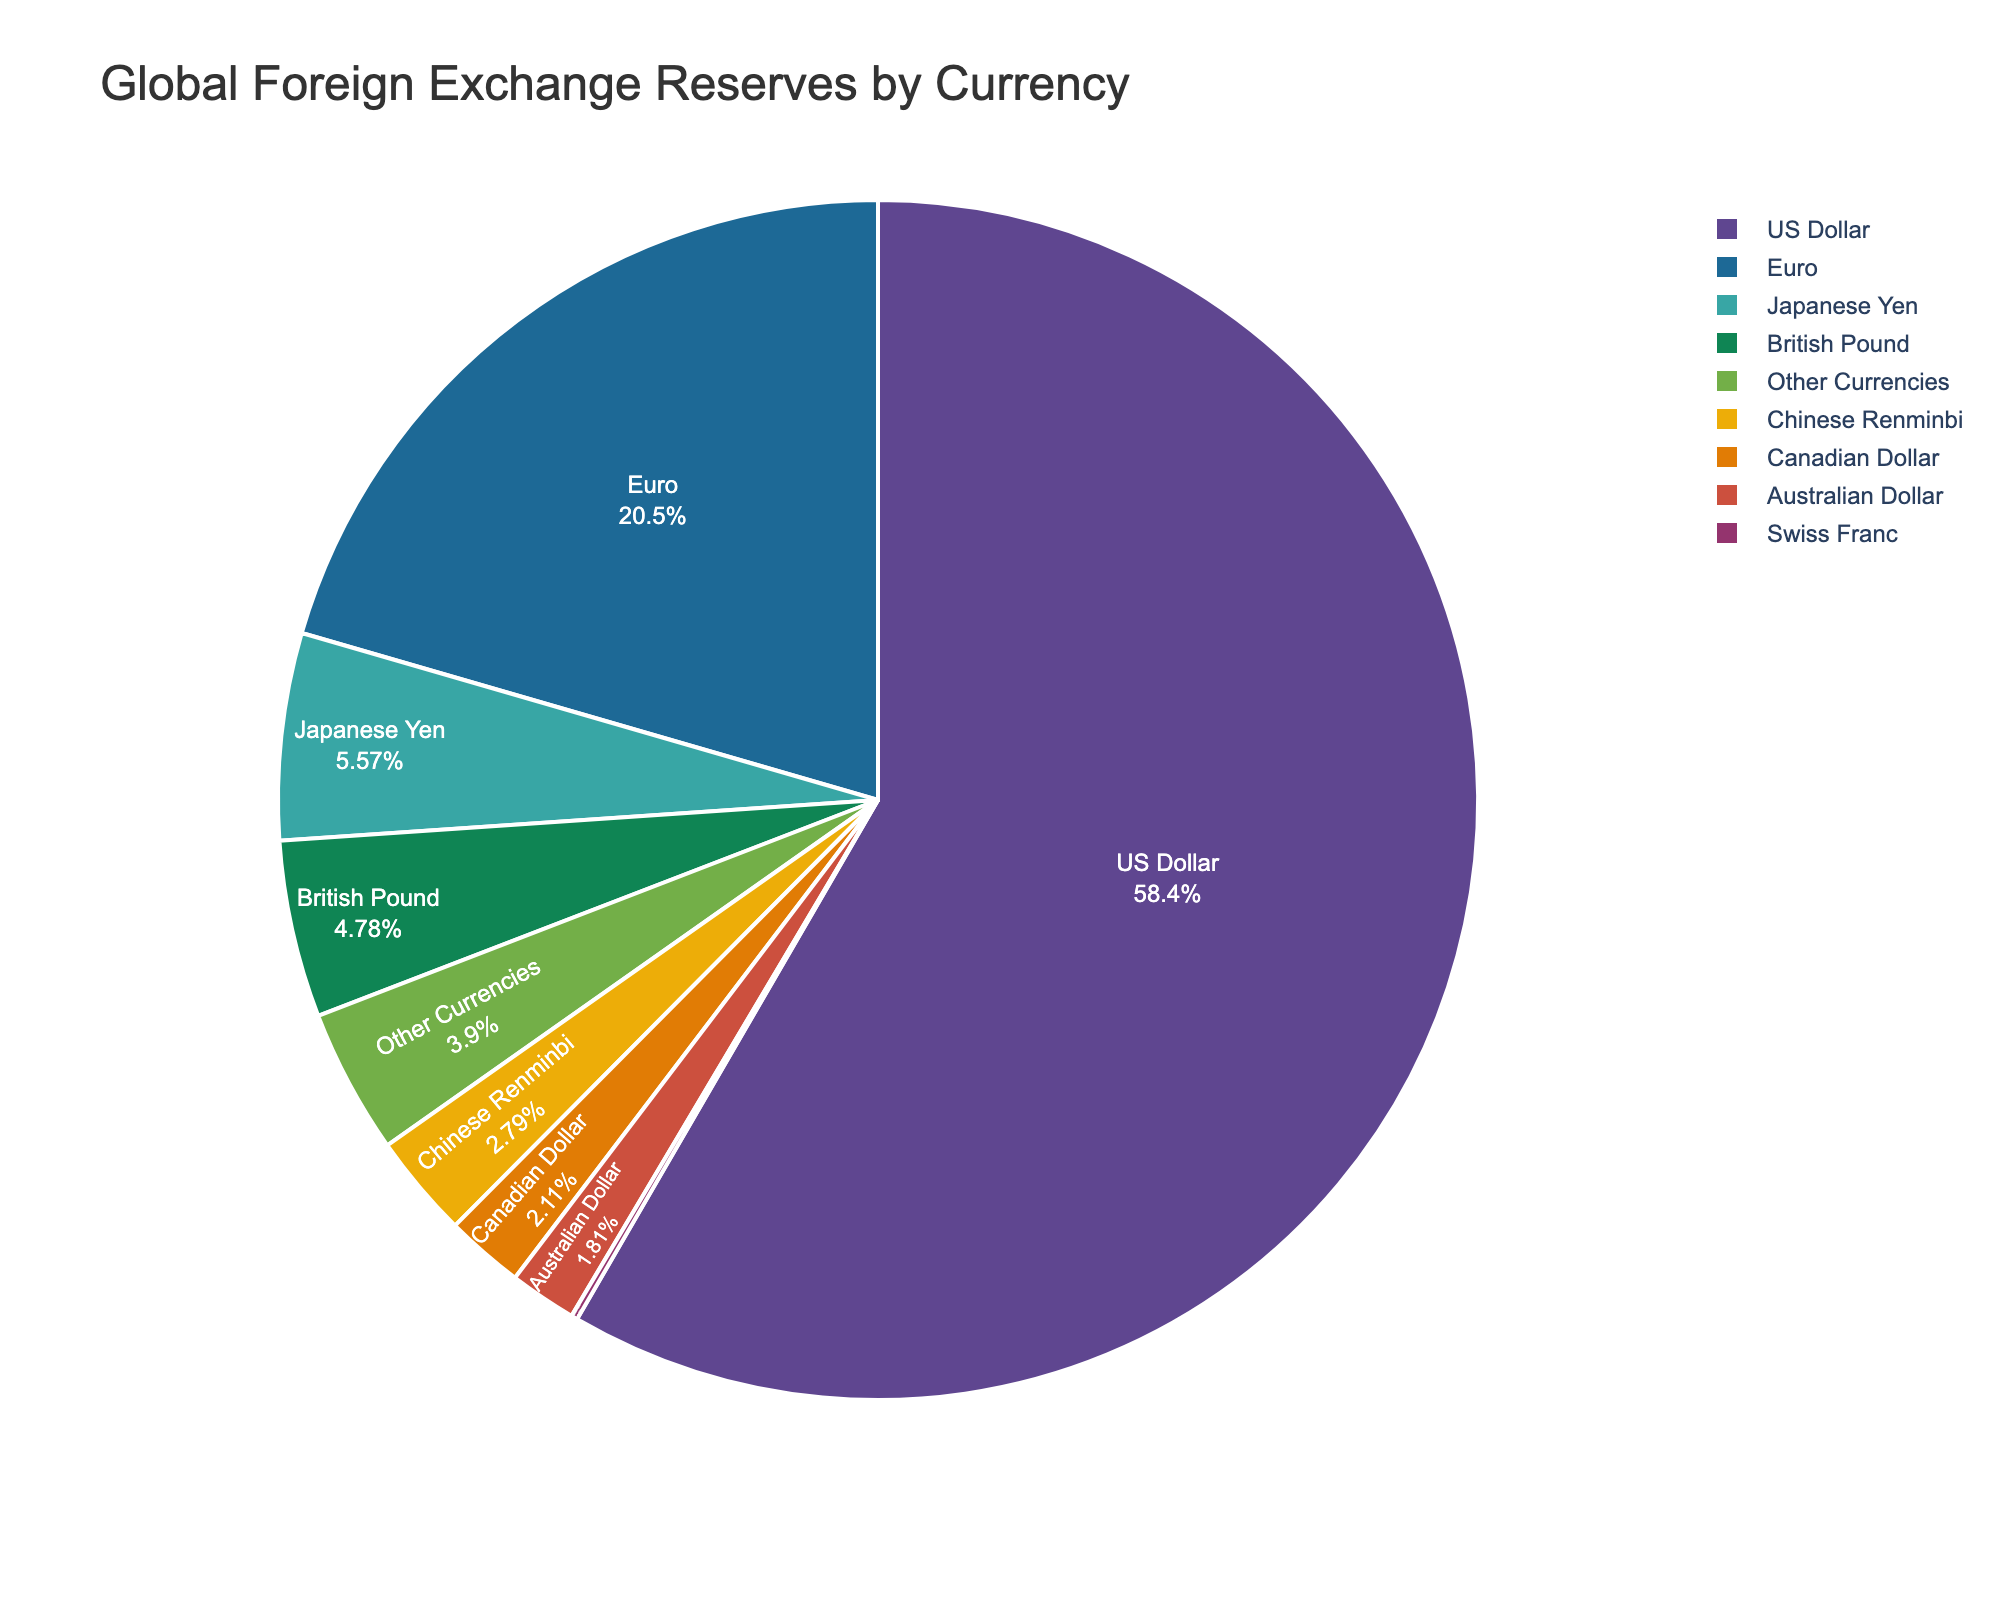What percentage of global foreign exchange reserves is held in the US Dollar and Euro combined? The US Dollar accounts for 58.36% and the Euro accounts for 20.51%. Adding these two percentages together, 58.36% + 20.51% = 78.87%.
Answer: 78.87% What is the difference in percentage points between the US Dollar and Chinese Renminbi holdings? The US Dollar is at 58.36% and the Chinese Renminbi is at 2.79%. Subtraction of these two percentages, 58.36% - 2.79% = 55.57%.
Answer: 55.57% Which currency represents the smallest portion of the global foreign exchange reserves? By observing the pie chart, the Swiss Franc has the smallest portion with 0.17%.
Answer: Swiss Franc Are the combined percentages of the Japanese Yen and British Pound lesser or greater than the Euro's percentage? The Japanese Yen accounts for 5.57% and the British Pound for 4.78%. Combined, they account for 5.57% + 4.78% = 10.35%, which is less than the Euro's 20.51%.
Answer: Lesser What is the total percentage represented by currencies other than the US Dollar, Euro, and Japanese Yen? Adding the remaining percentages: British Pound (4.78%), Chinese Renminbi (2.79%), Canadian Dollar (2.11%), Australian Dollar (1.81%), Swiss Franc (0.17%), Other Currencies (3.90%), resulting in 4.78% + 2.79% + 2.11% + 1.81% + 0.17% + 3.90% = 15.56%.
Answer: 15.56% Which color represents the British Pound in the pie chart? By identifying the color attributed to each currency slice in the pie chart, we find that the British Pound is represented in a shade distinct from other slices.
Answer: [the specific color] Which has a greater percentage: the Canadian Dollar or the Australian Dollar? By observing the pie chart, the Canadian Dollar has 2.11% while the Australian Dollar has 1.81%. The Canadian Dollar percentage is greater.
Answer: Canadian Dollar What is the approximate difference in percentage points between the Japanese Yen and the British Pound? The Japanese Yen is at 5.57% and the British Pound is at 4.78%. The difference is found by subtracting these values, 5.57% - 4.78% = 0.79%.
Answer: 0.79% 